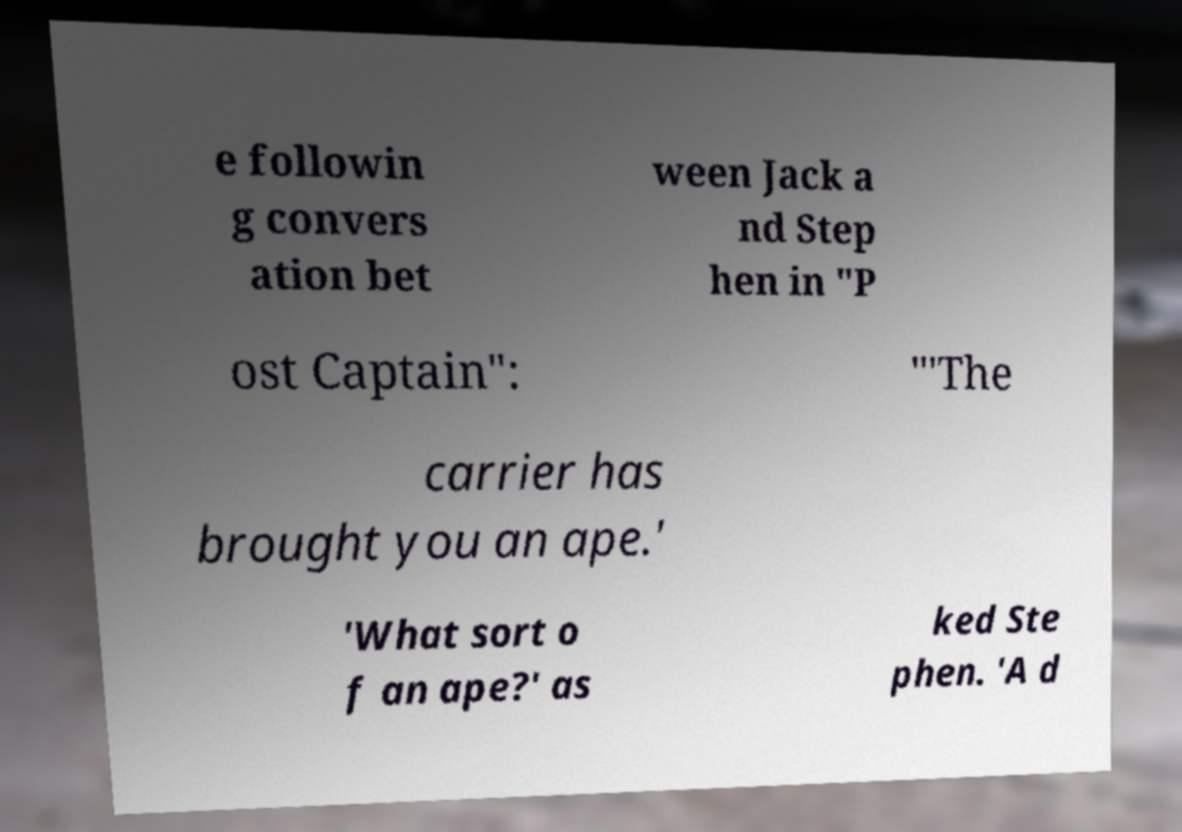Please read and relay the text visible in this image. What does it say? e followin g convers ation bet ween Jack a nd Step hen in "P ost Captain": "'The carrier has brought you an ape.' 'What sort o f an ape?' as ked Ste phen. 'A d 